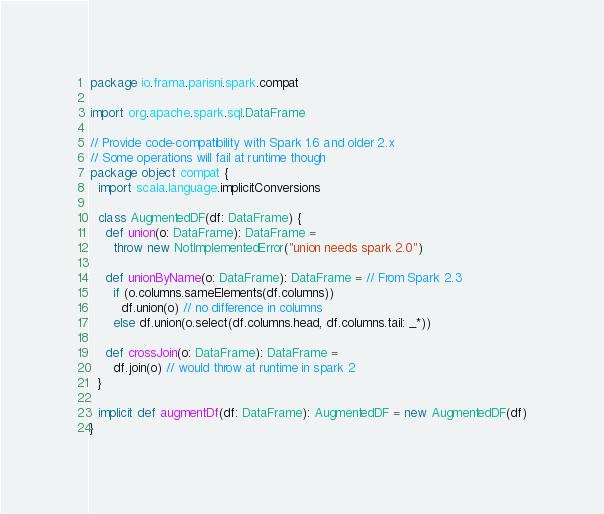Convert code to text. <code><loc_0><loc_0><loc_500><loc_500><_Scala_>package io.frama.parisni.spark.compat

import org.apache.spark.sql.DataFrame

// Provide code-compatibility with Spark 1.6 and older 2.x
// Some operations will fail at runtime though
package object compat {
  import scala.language.implicitConversions

  class AugmentedDF(df: DataFrame) {
    def union(o: DataFrame): DataFrame =
      throw new NotImplementedError("union needs spark 2.0")

    def unionByName(o: DataFrame): DataFrame = // From Spark 2.3
      if (o.columns.sameElements(df.columns))
        df.union(o) // no difference in columns
      else df.union(o.select(df.columns.head, df.columns.tail: _*))

    def crossJoin(o: DataFrame): DataFrame =
      df.join(o) // would throw at runtime in spark 2
  }

  implicit def augmentDf(df: DataFrame): AugmentedDF = new AugmentedDF(df)
}
</code> 